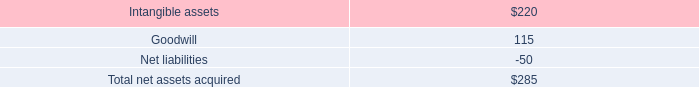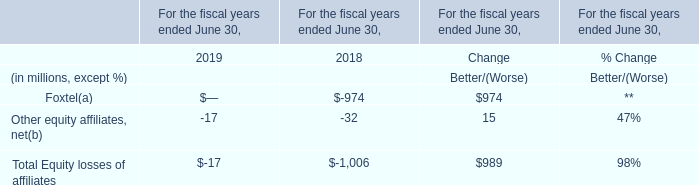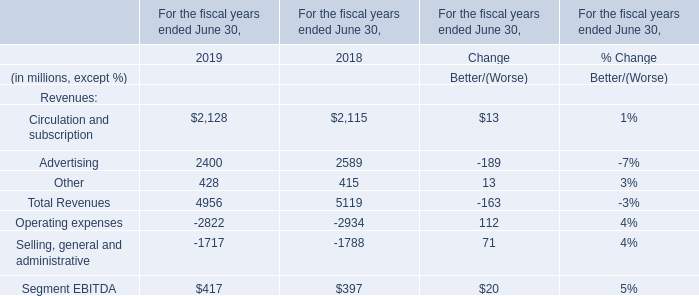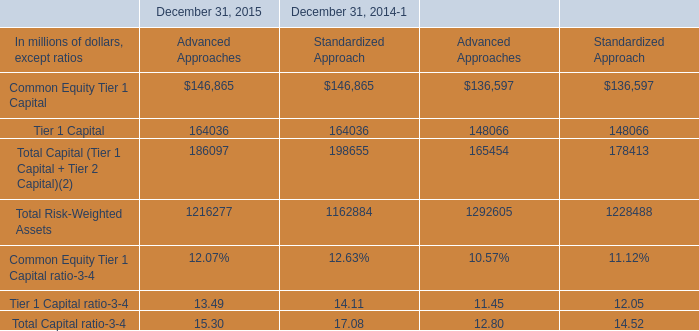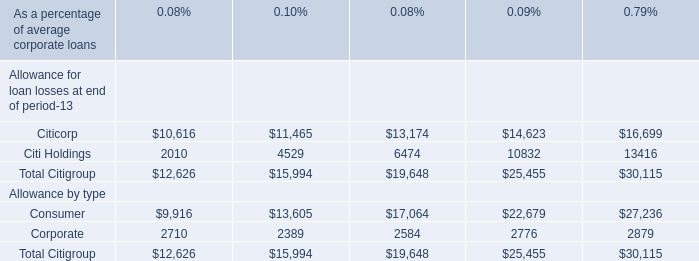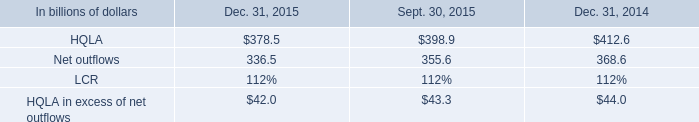what was the percent of the change in the hqla in the q4 and q3 of 2015 
Computations: ((378.5 - 398.9) / 398.9)
Answer: -0.05114. 